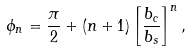<formula> <loc_0><loc_0><loc_500><loc_500>\phi _ { n } = { \frac { \pi } { 2 } } + ( n + 1 ) \left [ { \frac { b _ { c } } { b _ { s } } } \right ] ^ { n } ,</formula> 